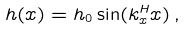Convert formula to latex. <formula><loc_0><loc_0><loc_500><loc_500>h ( x ) = h _ { 0 } \sin ( k _ { x } ^ { H } x ) \, ,</formula> 